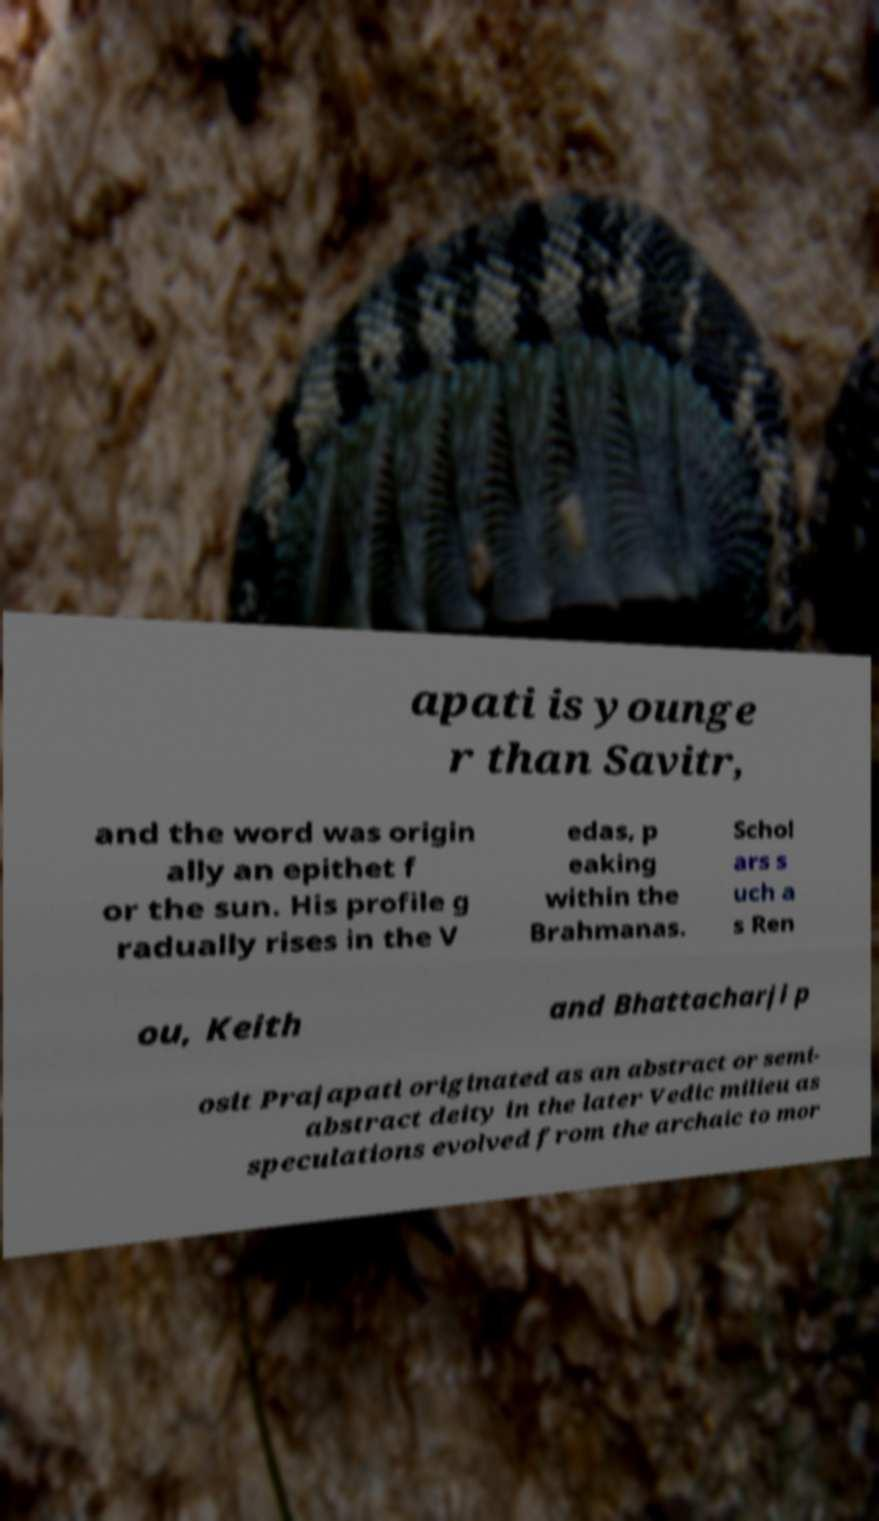For documentation purposes, I need the text within this image transcribed. Could you provide that? apati is younge r than Savitr, and the word was origin ally an epithet f or the sun. His profile g radually rises in the V edas, p eaking within the Brahmanas. Schol ars s uch a s Ren ou, Keith and Bhattacharji p osit Prajapati originated as an abstract or semi- abstract deity in the later Vedic milieu as speculations evolved from the archaic to mor 